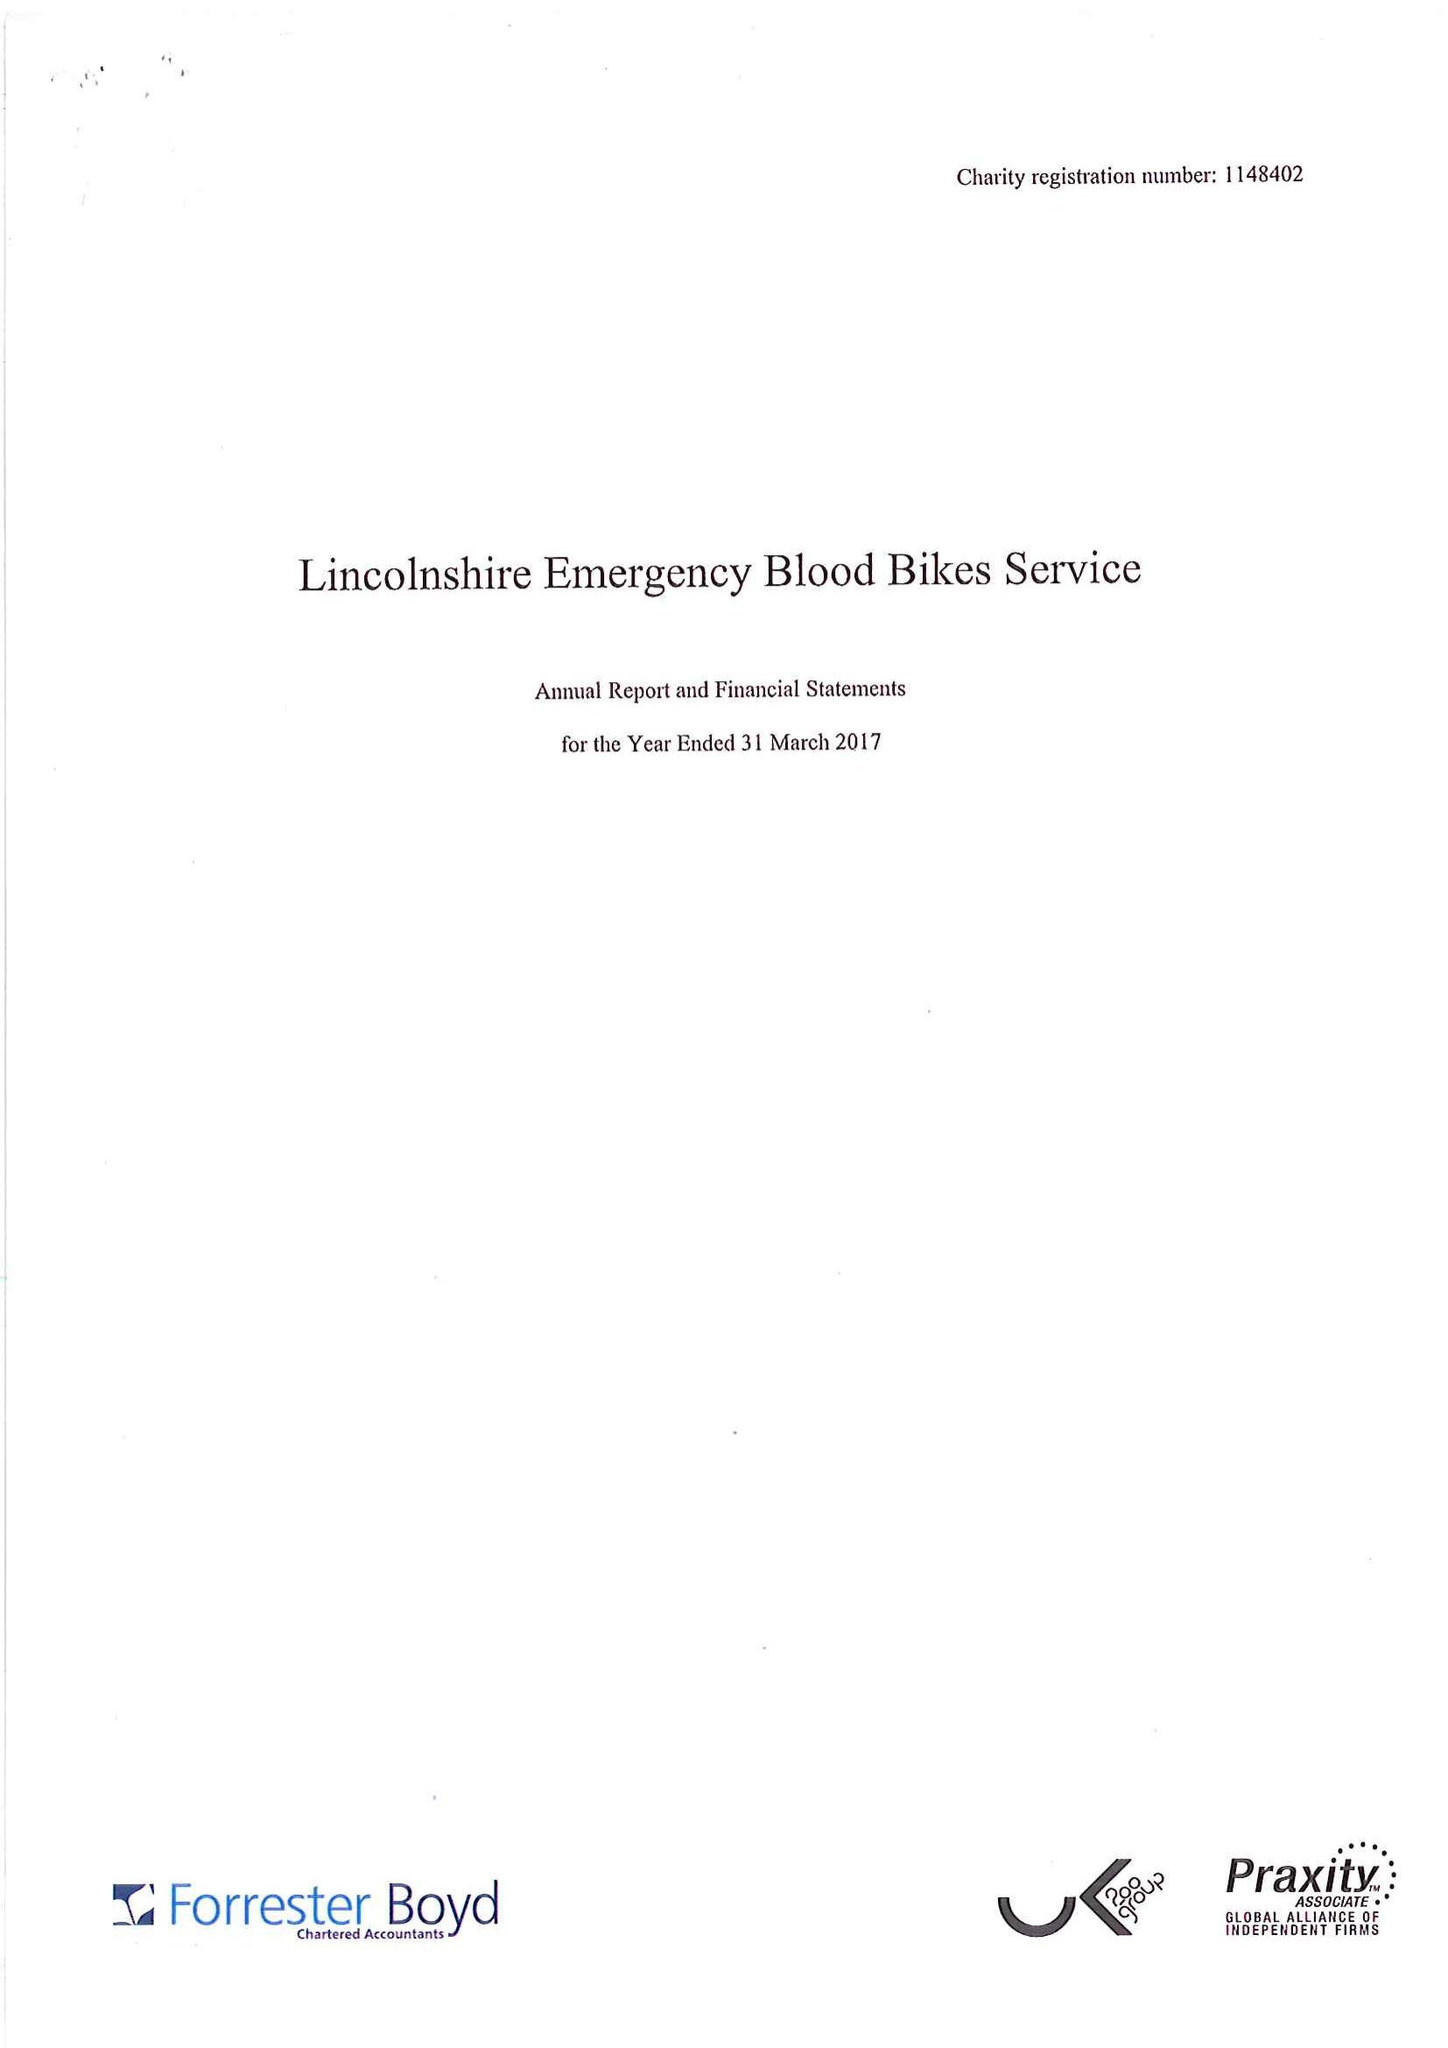What is the value for the spending_annually_in_british_pounds?
Answer the question using a single word or phrase. 29972.00 